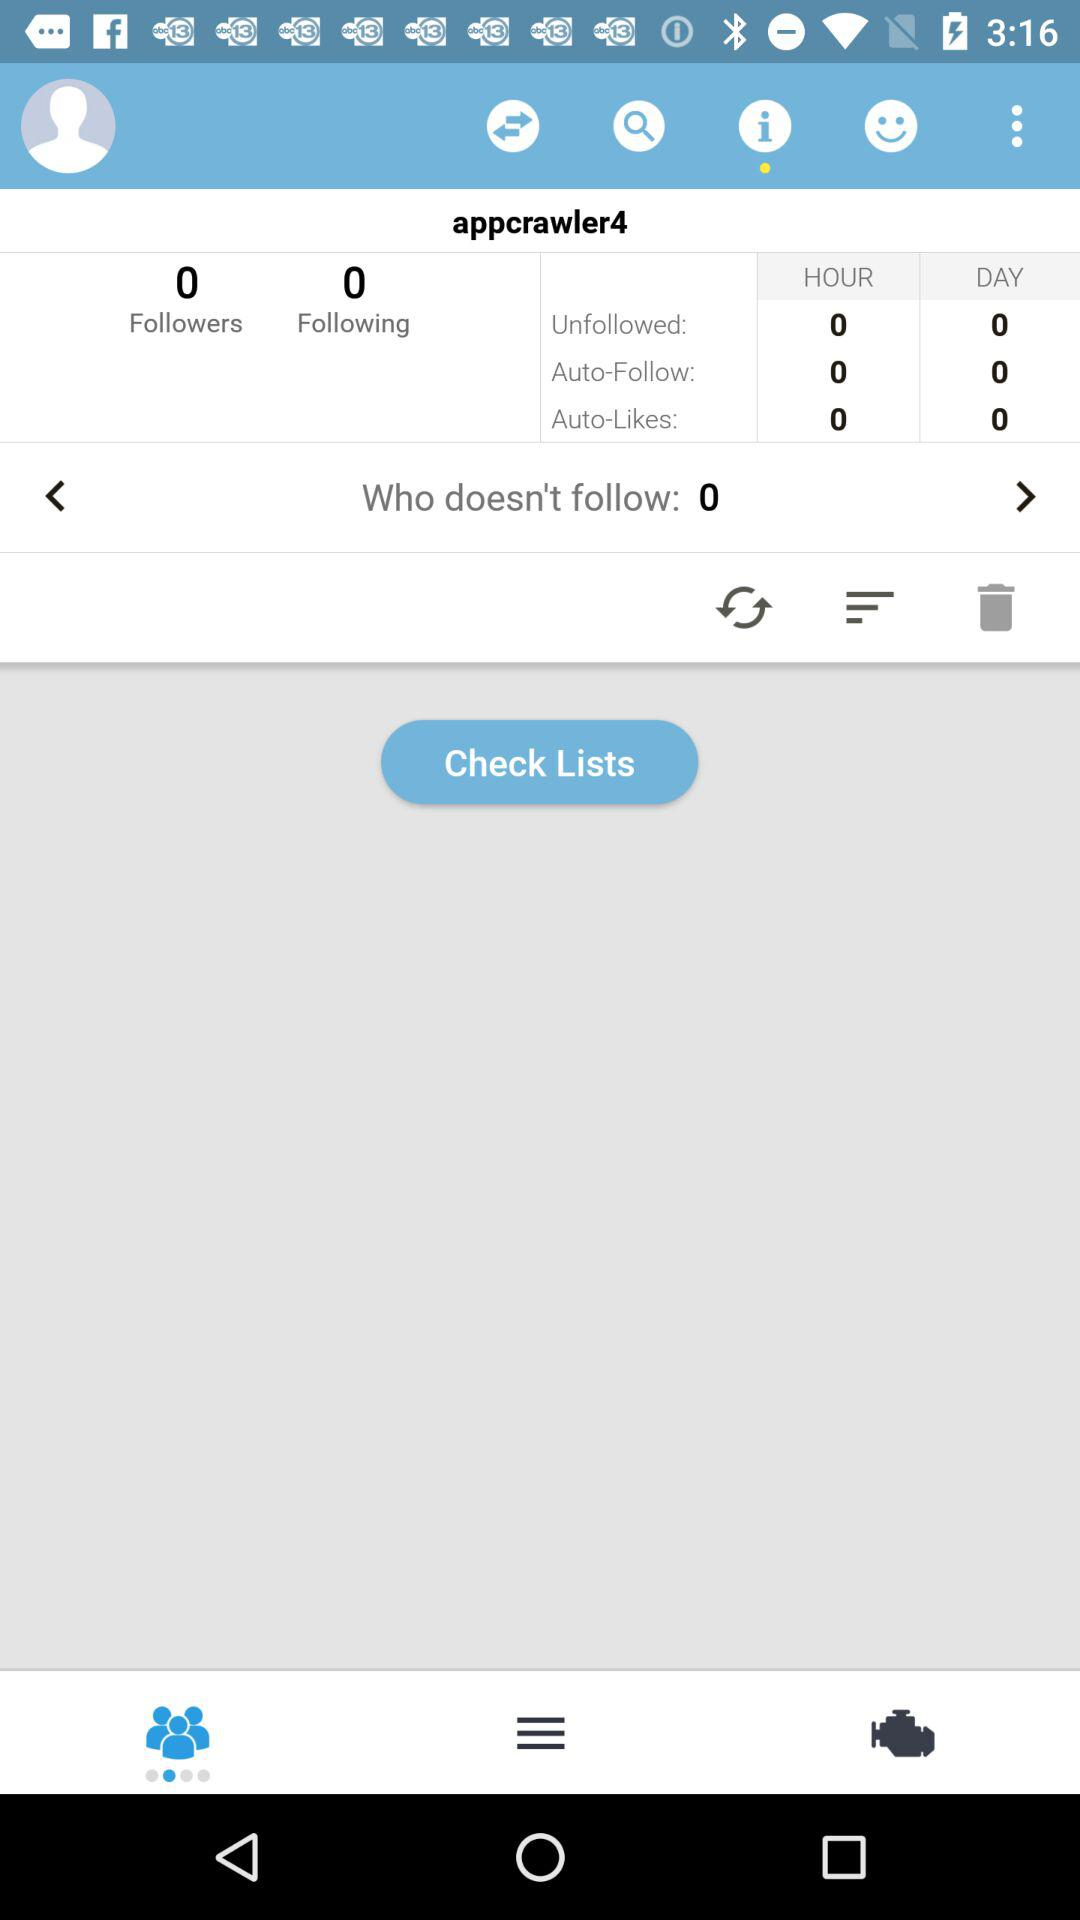What's the count of the following people? The count is 0. 